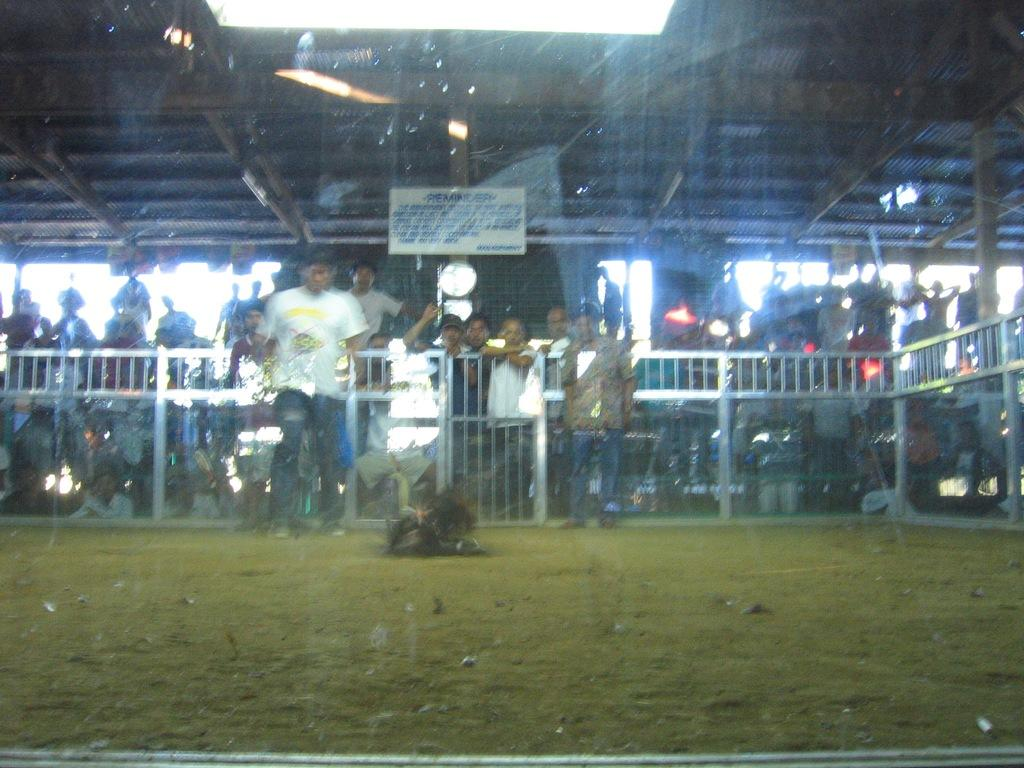What can be seen in the image in terms of human presence? There are people standing in the image. What type of animal is present on the ground in the image? There is a bird on the ground in the image. What is the ground covered with in the image? There is grass on the ground in the image. What can be seen in the background of the image? There is a hoarding visible in the background of the image. What sound can be heard coming from the bird in the image? The image does not provide any auditory information, so it is not possible to determine what sound the bird might be making. 